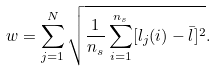Convert formula to latex. <formula><loc_0><loc_0><loc_500><loc_500>w = \sum _ { j = 1 } ^ { N } \sqrt { \frac { 1 } { n _ { s } } \sum _ { i = 1 } ^ { n _ { s } } [ l _ { j } ( i ) - \bar { l } ] ^ { 2 } } .</formula> 